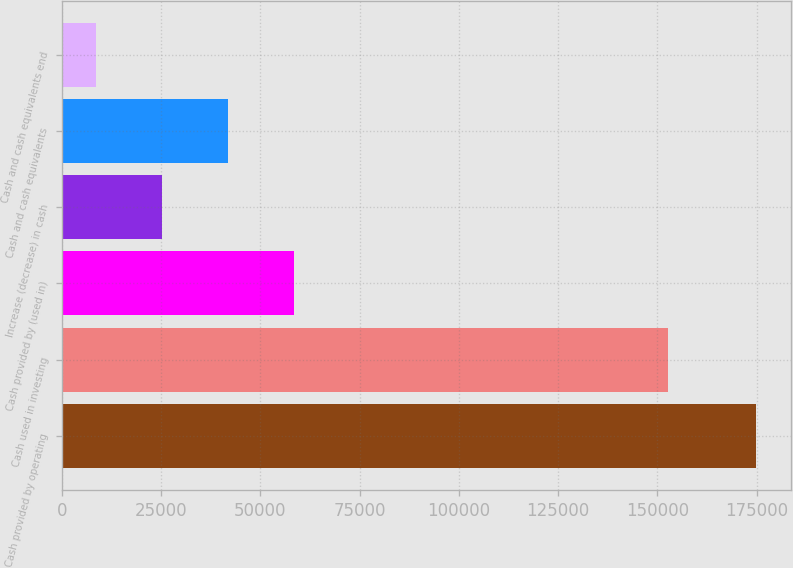Convert chart. <chart><loc_0><loc_0><loc_500><loc_500><bar_chart><fcel>Cash provided by operating<fcel>Cash used in investing<fcel>Cash provided by (used in)<fcel>Increase (decrease) in cash<fcel>Cash and cash equivalents<fcel>Cash and cash equivalents end<nl><fcel>174941<fcel>152730<fcel>58529.6<fcel>25269.2<fcel>41899.4<fcel>8639<nl></chart> 